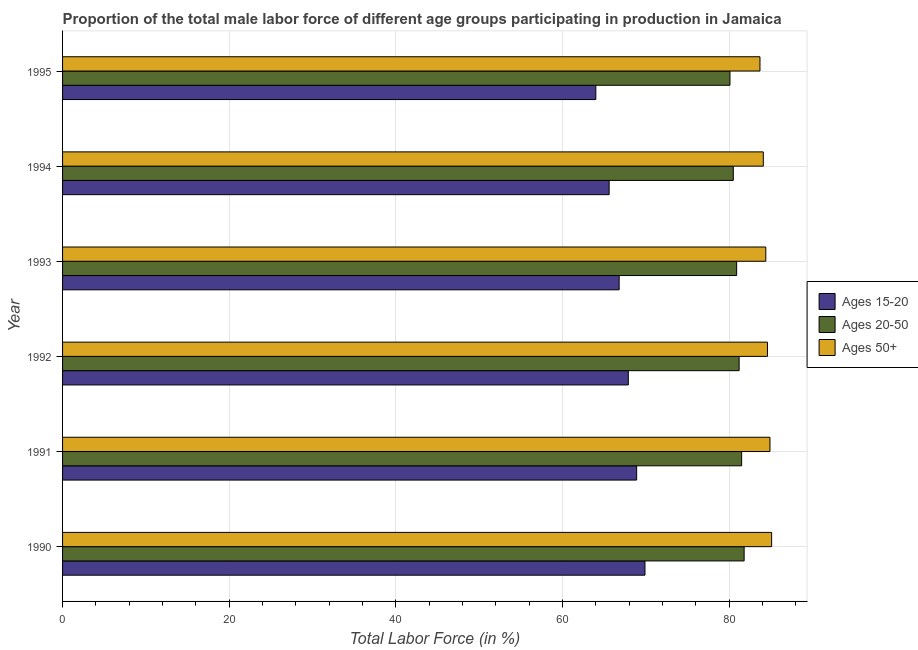How many bars are there on the 5th tick from the bottom?
Keep it short and to the point. 3. In how many cases, is the number of bars for a given year not equal to the number of legend labels?
Give a very brief answer. 0. What is the percentage of male labor force within the age group 20-50 in 1990?
Give a very brief answer. 81.8. Across all years, what is the maximum percentage of male labor force within the age group 15-20?
Provide a short and direct response. 69.9. Across all years, what is the minimum percentage of male labor force within the age group 20-50?
Provide a short and direct response. 80.1. What is the total percentage of male labor force within the age group 20-50 in the graph?
Ensure brevity in your answer.  486. What is the difference between the percentage of male labor force within the age group 15-20 in 1992 and that in 1994?
Your answer should be compact. 2.3. What is the difference between the percentage of male labor force within the age group 20-50 in 1995 and the percentage of male labor force within the age group 15-20 in 1990?
Give a very brief answer. 10.2. What is the average percentage of male labor force above age 50 per year?
Your answer should be compact. 84.47. In the year 1992, what is the difference between the percentage of male labor force within the age group 20-50 and percentage of male labor force above age 50?
Keep it short and to the point. -3.4. What is the ratio of the percentage of male labor force within the age group 15-20 in 1991 to that in 1995?
Give a very brief answer. 1.08. What is the difference between the highest and the second highest percentage of male labor force within the age group 15-20?
Offer a very short reply. 1. In how many years, is the percentage of male labor force within the age group 15-20 greater than the average percentage of male labor force within the age group 15-20 taken over all years?
Make the answer very short. 3. Is the sum of the percentage of male labor force within the age group 20-50 in 1992 and 1993 greater than the maximum percentage of male labor force above age 50 across all years?
Provide a short and direct response. Yes. What does the 3rd bar from the top in 1991 represents?
Keep it short and to the point. Ages 15-20. What does the 2nd bar from the bottom in 1995 represents?
Provide a short and direct response. Ages 20-50. Is it the case that in every year, the sum of the percentage of male labor force within the age group 15-20 and percentage of male labor force within the age group 20-50 is greater than the percentage of male labor force above age 50?
Your response must be concise. Yes. How many bars are there?
Provide a short and direct response. 18. Are all the bars in the graph horizontal?
Your answer should be compact. Yes. How many years are there in the graph?
Keep it short and to the point. 6. Does the graph contain any zero values?
Offer a terse response. No. Where does the legend appear in the graph?
Ensure brevity in your answer.  Center right. How many legend labels are there?
Keep it short and to the point. 3. What is the title of the graph?
Ensure brevity in your answer.  Proportion of the total male labor force of different age groups participating in production in Jamaica. Does "New Zealand" appear as one of the legend labels in the graph?
Make the answer very short. No. What is the label or title of the Y-axis?
Your response must be concise. Year. What is the Total Labor Force (in %) of Ages 15-20 in 1990?
Ensure brevity in your answer.  69.9. What is the Total Labor Force (in %) in Ages 20-50 in 1990?
Offer a very short reply. 81.8. What is the Total Labor Force (in %) in Ages 50+ in 1990?
Ensure brevity in your answer.  85.1. What is the Total Labor Force (in %) of Ages 15-20 in 1991?
Your response must be concise. 68.9. What is the Total Labor Force (in %) of Ages 20-50 in 1991?
Provide a short and direct response. 81.5. What is the Total Labor Force (in %) of Ages 50+ in 1991?
Your answer should be very brief. 84.9. What is the Total Labor Force (in %) in Ages 15-20 in 1992?
Keep it short and to the point. 67.9. What is the Total Labor Force (in %) of Ages 20-50 in 1992?
Your response must be concise. 81.2. What is the Total Labor Force (in %) in Ages 50+ in 1992?
Your answer should be compact. 84.6. What is the Total Labor Force (in %) in Ages 15-20 in 1993?
Make the answer very short. 66.8. What is the Total Labor Force (in %) of Ages 20-50 in 1993?
Your response must be concise. 80.9. What is the Total Labor Force (in %) in Ages 50+ in 1993?
Ensure brevity in your answer.  84.4. What is the Total Labor Force (in %) in Ages 15-20 in 1994?
Your response must be concise. 65.6. What is the Total Labor Force (in %) in Ages 20-50 in 1994?
Give a very brief answer. 80.5. What is the Total Labor Force (in %) in Ages 50+ in 1994?
Provide a short and direct response. 84.1. What is the Total Labor Force (in %) in Ages 15-20 in 1995?
Ensure brevity in your answer.  64. What is the Total Labor Force (in %) in Ages 20-50 in 1995?
Your answer should be compact. 80.1. What is the Total Labor Force (in %) of Ages 50+ in 1995?
Your answer should be compact. 83.7. Across all years, what is the maximum Total Labor Force (in %) in Ages 15-20?
Give a very brief answer. 69.9. Across all years, what is the maximum Total Labor Force (in %) in Ages 20-50?
Give a very brief answer. 81.8. Across all years, what is the maximum Total Labor Force (in %) in Ages 50+?
Keep it short and to the point. 85.1. Across all years, what is the minimum Total Labor Force (in %) of Ages 15-20?
Your response must be concise. 64. Across all years, what is the minimum Total Labor Force (in %) in Ages 20-50?
Ensure brevity in your answer.  80.1. Across all years, what is the minimum Total Labor Force (in %) in Ages 50+?
Make the answer very short. 83.7. What is the total Total Labor Force (in %) in Ages 15-20 in the graph?
Your answer should be very brief. 403.1. What is the total Total Labor Force (in %) in Ages 20-50 in the graph?
Keep it short and to the point. 486. What is the total Total Labor Force (in %) of Ages 50+ in the graph?
Provide a short and direct response. 506.8. What is the difference between the Total Labor Force (in %) in Ages 15-20 in 1990 and that in 1991?
Offer a terse response. 1. What is the difference between the Total Labor Force (in %) in Ages 50+ in 1990 and that in 1991?
Ensure brevity in your answer.  0.2. What is the difference between the Total Labor Force (in %) of Ages 15-20 in 1990 and that in 1992?
Provide a short and direct response. 2. What is the difference between the Total Labor Force (in %) of Ages 50+ in 1990 and that in 1993?
Provide a short and direct response. 0.7. What is the difference between the Total Labor Force (in %) of Ages 15-20 in 1990 and that in 1995?
Your answer should be compact. 5.9. What is the difference between the Total Labor Force (in %) in Ages 20-50 in 1990 and that in 1995?
Offer a very short reply. 1.7. What is the difference between the Total Labor Force (in %) in Ages 50+ in 1990 and that in 1995?
Offer a very short reply. 1.4. What is the difference between the Total Labor Force (in %) in Ages 20-50 in 1991 and that in 1992?
Provide a short and direct response. 0.3. What is the difference between the Total Labor Force (in %) of Ages 50+ in 1991 and that in 1992?
Make the answer very short. 0.3. What is the difference between the Total Labor Force (in %) of Ages 15-20 in 1991 and that in 1993?
Make the answer very short. 2.1. What is the difference between the Total Labor Force (in %) in Ages 15-20 in 1991 and that in 1994?
Provide a succinct answer. 3.3. What is the difference between the Total Labor Force (in %) in Ages 20-50 in 1991 and that in 1994?
Ensure brevity in your answer.  1. What is the difference between the Total Labor Force (in %) of Ages 50+ in 1991 and that in 1994?
Make the answer very short. 0.8. What is the difference between the Total Labor Force (in %) of Ages 15-20 in 1991 and that in 1995?
Offer a terse response. 4.9. What is the difference between the Total Labor Force (in %) of Ages 20-50 in 1991 and that in 1995?
Offer a very short reply. 1.4. What is the difference between the Total Labor Force (in %) of Ages 50+ in 1991 and that in 1995?
Provide a succinct answer. 1.2. What is the difference between the Total Labor Force (in %) of Ages 15-20 in 1992 and that in 1994?
Ensure brevity in your answer.  2.3. What is the difference between the Total Labor Force (in %) of Ages 50+ in 1992 and that in 1994?
Offer a terse response. 0.5. What is the difference between the Total Labor Force (in %) of Ages 15-20 in 1992 and that in 1995?
Keep it short and to the point. 3.9. What is the difference between the Total Labor Force (in %) in Ages 50+ in 1992 and that in 1995?
Offer a very short reply. 0.9. What is the difference between the Total Labor Force (in %) of Ages 50+ in 1993 and that in 1994?
Make the answer very short. 0.3. What is the difference between the Total Labor Force (in %) of Ages 20-50 in 1993 and that in 1995?
Offer a very short reply. 0.8. What is the difference between the Total Labor Force (in %) of Ages 50+ in 1993 and that in 1995?
Your answer should be very brief. 0.7. What is the difference between the Total Labor Force (in %) in Ages 20-50 in 1990 and the Total Labor Force (in %) in Ages 50+ in 1991?
Give a very brief answer. -3.1. What is the difference between the Total Labor Force (in %) in Ages 15-20 in 1990 and the Total Labor Force (in %) in Ages 50+ in 1992?
Provide a succinct answer. -14.7. What is the difference between the Total Labor Force (in %) in Ages 15-20 in 1990 and the Total Labor Force (in %) in Ages 50+ in 1993?
Offer a very short reply. -14.5. What is the difference between the Total Labor Force (in %) of Ages 20-50 in 1990 and the Total Labor Force (in %) of Ages 50+ in 1993?
Offer a terse response. -2.6. What is the difference between the Total Labor Force (in %) in Ages 15-20 in 1990 and the Total Labor Force (in %) in Ages 20-50 in 1995?
Offer a terse response. -10.2. What is the difference between the Total Labor Force (in %) of Ages 15-20 in 1991 and the Total Labor Force (in %) of Ages 50+ in 1992?
Your answer should be very brief. -15.7. What is the difference between the Total Labor Force (in %) of Ages 20-50 in 1991 and the Total Labor Force (in %) of Ages 50+ in 1992?
Make the answer very short. -3.1. What is the difference between the Total Labor Force (in %) in Ages 15-20 in 1991 and the Total Labor Force (in %) in Ages 50+ in 1993?
Ensure brevity in your answer.  -15.5. What is the difference between the Total Labor Force (in %) in Ages 15-20 in 1991 and the Total Labor Force (in %) in Ages 50+ in 1994?
Your response must be concise. -15.2. What is the difference between the Total Labor Force (in %) of Ages 20-50 in 1991 and the Total Labor Force (in %) of Ages 50+ in 1994?
Provide a succinct answer. -2.6. What is the difference between the Total Labor Force (in %) of Ages 15-20 in 1991 and the Total Labor Force (in %) of Ages 20-50 in 1995?
Make the answer very short. -11.2. What is the difference between the Total Labor Force (in %) in Ages 15-20 in 1991 and the Total Labor Force (in %) in Ages 50+ in 1995?
Give a very brief answer. -14.8. What is the difference between the Total Labor Force (in %) of Ages 20-50 in 1991 and the Total Labor Force (in %) of Ages 50+ in 1995?
Keep it short and to the point. -2.2. What is the difference between the Total Labor Force (in %) in Ages 15-20 in 1992 and the Total Labor Force (in %) in Ages 20-50 in 1993?
Make the answer very short. -13. What is the difference between the Total Labor Force (in %) in Ages 15-20 in 1992 and the Total Labor Force (in %) in Ages 50+ in 1993?
Your answer should be very brief. -16.5. What is the difference between the Total Labor Force (in %) in Ages 15-20 in 1992 and the Total Labor Force (in %) in Ages 50+ in 1994?
Provide a short and direct response. -16.2. What is the difference between the Total Labor Force (in %) in Ages 15-20 in 1992 and the Total Labor Force (in %) in Ages 20-50 in 1995?
Make the answer very short. -12.2. What is the difference between the Total Labor Force (in %) in Ages 15-20 in 1992 and the Total Labor Force (in %) in Ages 50+ in 1995?
Give a very brief answer. -15.8. What is the difference between the Total Labor Force (in %) in Ages 20-50 in 1992 and the Total Labor Force (in %) in Ages 50+ in 1995?
Provide a short and direct response. -2.5. What is the difference between the Total Labor Force (in %) in Ages 15-20 in 1993 and the Total Labor Force (in %) in Ages 20-50 in 1994?
Your answer should be compact. -13.7. What is the difference between the Total Labor Force (in %) in Ages 15-20 in 1993 and the Total Labor Force (in %) in Ages 50+ in 1994?
Provide a succinct answer. -17.3. What is the difference between the Total Labor Force (in %) of Ages 20-50 in 1993 and the Total Labor Force (in %) of Ages 50+ in 1994?
Keep it short and to the point. -3.2. What is the difference between the Total Labor Force (in %) of Ages 15-20 in 1993 and the Total Labor Force (in %) of Ages 50+ in 1995?
Offer a terse response. -16.9. What is the difference between the Total Labor Force (in %) in Ages 20-50 in 1993 and the Total Labor Force (in %) in Ages 50+ in 1995?
Your response must be concise. -2.8. What is the difference between the Total Labor Force (in %) of Ages 15-20 in 1994 and the Total Labor Force (in %) of Ages 50+ in 1995?
Ensure brevity in your answer.  -18.1. What is the average Total Labor Force (in %) in Ages 15-20 per year?
Provide a short and direct response. 67.18. What is the average Total Labor Force (in %) of Ages 50+ per year?
Make the answer very short. 84.47. In the year 1990, what is the difference between the Total Labor Force (in %) of Ages 15-20 and Total Labor Force (in %) of Ages 20-50?
Offer a terse response. -11.9. In the year 1990, what is the difference between the Total Labor Force (in %) in Ages 15-20 and Total Labor Force (in %) in Ages 50+?
Give a very brief answer. -15.2. In the year 1990, what is the difference between the Total Labor Force (in %) in Ages 20-50 and Total Labor Force (in %) in Ages 50+?
Give a very brief answer. -3.3. In the year 1991, what is the difference between the Total Labor Force (in %) of Ages 15-20 and Total Labor Force (in %) of Ages 20-50?
Your response must be concise. -12.6. In the year 1991, what is the difference between the Total Labor Force (in %) in Ages 15-20 and Total Labor Force (in %) in Ages 50+?
Your answer should be compact. -16. In the year 1991, what is the difference between the Total Labor Force (in %) in Ages 20-50 and Total Labor Force (in %) in Ages 50+?
Offer a very short reply. -3.4. In the year 1992, what is the difference between the Total Labor Force (in %) in Ages 15-20 and Total Labor Force (in %) in Ages 50+?
Your answer should be very brief. -16.7. In the year 1992, what is the difference between the Total Labor Force (in %) of Ages 20-50 and Total Labor Force (in %) of Ages 50+?
Your response must be concise. -3.4. In the year 1993, what is the difference between the Total Labor Force (in %) of Ages 15-20 and Total Labor Force (in %) of Ages 20-50?
Your answer should be compact. -14.1. In the year 1993, what is the difference between the Total Labor Force (in %) in Ages 15-20 and Total Labor Force (in %) in Ages 50+?
Make the answer very short. -17.6. In the year 1993, what is the difference between the Total Labor Force (in %) in Ages 20-50 and Total Labor Force (in %) in Ages 50+?
Your answer should be very brief. -3.5. In the year 1994, what is the difference between the Total Labor Force (in %) in Ages 15-20 and Total Labor Force (in %) in Ages 20-50?
Give a very brief answer. -14.9. In the year 1994, what is the difference between the Total Labor Force (in %) of Ages 15-20 and Total Labor Force (in %) of Ages 50+?
Give a very brief answer. -18.5. In the year 1994, what is the difference between the Total Labor Force (in %) of Ages 20-50 and Total Labor Force (in %) of Ages 50+?
Make the answer very short. -3.6. In the year 1995, what is the difference between the Total Labor Force (in %) of Ages 15-20 and Total Labor Force (in %) of Ages 20-50?
Keep it short and to the point. -16.1. In the year 1995, what is the difference between the Total Labor Force (in %) in Ages 15-20 and Total Labor Force (in %) in Ages 50+?
Make the answer very short. -19.7. In the year 1995, what is the difference between the Total Labor Force (in %) of Ages 20-50 and Total Labor Force (in %) of Ages 50+?
Keep it short and to the point. -3.6. What is the ratio of the Total Labor Force (in %) in Ages 15-20 in 1990 to that in 1991?
Your answer should be very brief. 1.01. What is the ratio of the Total Labor Force (in %) in Ages 20-50 in 1990 to that in 1991?
Your answer should be very brief. 1. What is the ratio of the Total Labor Force (in %) of Ages 15-20 in 1990 to that in 1992?
Your answer should be very brief. 1.03. What is the ratio of the Total Labor Force (in %) of Ages 20-50 in 1990 to that in 1992?
Your answer should be very brief. 1.01. What is the ratio of the Total Labor Force (in %) of Ages 50+ in 1990 to that in 1992?
Provide a short and direct response. 1.01. What is the ratio of the Total Labor Force (in %) in Ages 15-20 in 1990 to that in 1993?
Your answer should be compact. 1.05. What is the ratio of the Total Labor Force (in %) in Ages 20-50 in 1990 to that in 1993?
Keep it short and to the point. 1.01. What is the ratio of the Total Labor Force (in %) in Ages 50+ in 1990 to that in 1993?
Offer a very short reply. 1.01. What is the ratio of the Total Labor Force (in %) of Ages 15-20 in 1990 to that in 1994?
Ensure brevity in your answer.  1.07. What is the ratio of the Total Labor Force (in %) of Ages 20-50 in 1990 to that in 1994?
Ensure brevity in your answer.  1.02. What is the ratio of the Total Labor Force (in %) of Ages 50+ in 1990 to that in 1994?
Offer a very short reply. 1.01. What is the ratio of the Total Labor Force (in %) in Ages 15-20 in 1990 to that in 1995?
Provide a short and direct response. 1.09. What is the ratio of the Total Labor Force (in %) of Ages 20-50 in 1990 to that in 1995?
Ensure brevity in your answer.  1.02. What is the ratio of the Total Labor Force (in %) in Ages 50+ in 1990 to that in 1995?
Make the answer very short. 1.02. What is the ratio of the Total Labor Force (in %) of Ages 15-20 in 1991 to that in 1992?
Make the answer very short. 1.01. What is the ratio of the Total Labor Force (in %) in Ages 20-50 in 1991 to that in 1992?
Keep it short and to the point. 1. What is the ratio of the Total Labor Force (in %) of Ages 50+ in 1991 to that in 1992?
Your answer should be very brief. 1. What is the ratio of the Total Labor Force (in %) of Ages 15-20 in 1991 to that in 1993?
Keep it short and to the point. 1.03. What is the ratio of the Total Labor Force (in %) of Ages 20-50 in 1991 to that in 1993?
Give a very brief answer. 1.01. What is the ratio of the Total Labor Force (in %) in Ages 50+ in 1991 to that in 1993?
Make the answer very short. 1.01. What is the ratio of the Total Labor Force (in %) in Ages 15-20 in 1991 to that in 1994?
Your response must be concise. 1.05. What is the ratio of the Total Labor Force (in %) in Ages 20-50 in 1991 to that in 1994?
Offer a very short reply. 1.01. What is the ratio of the Total Labor Force (in %) of Ages 50+ in 1991 to that in 1994?
Give a very brief answer. 1.01. What is the ratio of the Total Labor Force (in %) in Ages 15-20 in 1991 to that in 1995?
Make the answer very short. 1.08. What is the ratio of the Total Labor Force (in %) of Ages 20-50 in 1991 to that in 1995?
Offer a very short reply. 1.02. What is the ratio of the Total Labor Force (in %) of Ages 50+ in 1991 to that in 1995?
Your answer should be compact. 1.01. What is the ratio of the Total Labor Force (in %) in Ages 15-20 in 1992 to that in 1993?
Offer a terse response. 1.02. What is the ratio of the Total Labor Force (in %) in Ages 20-50 in 1992 to that in 1993?
Provide a succinct answer. 1. What is the ratio of the Total Labor Force (in %) of Ages 15-20 in 1992 to that in 1994?
Offer a very short reply. 1.04. What is the ratio of the Total Labor Force (in %) of Ages 20-50 in 1992 to that in 1994?
Offer a terse response. 1.01. What is the ratio of the Total Labor Force (in %) in Ages 50+ in 1992 to that in 1994?
Ensure brevity in your answer.  1.01. What is the ratio of the Total Labor Force (in %) in Ages 15-20 in 1992 to that in 1995?
Your answer should be compact. 1.06. What is the ratio of the Total Labor Force (in %) of Ages 20-50 in 1992 to that in 1995?
Ensure brevity in your answer.  1.01. What is the ratio of the Total Labor Force (in %) in Ages 50+ in 1992 to that in 1995?
Keep it short and to the point. 1.01. What is the ratio of the Total Labor Force (in %) in Ages 15-20 in 1993 to that in 1994?
Your answer should be very brief. 1.02. What is the ratio of the Total Labor Force (in %) in Ages 15-20 in 1993 to that in 1995?
Provide a short and direct response. 1.04. What is the ratio of the Total Labor Force (in %) in Ages 20-50 in 1993 to that in 1995?
Your answer should be compact. 1.01. What is the ratio of the Total Labor Force (in %) of Ages 50+ in 1993 to that in 1995?
Make the answer very short. 1.01. What is the ratio of the Total Labor Force (in %) in Ages 20-50 in 1994 to that in 1995?
Your response must be concise. 1. What is the difference between the highest and the second highest Total Labor Force (in %) of Ages 20-50?
Your response must be concise. 0.3. What is the difference between the highest and the lowest Total Labor Force (in %) of Ages 15-20?
Offer a very short reply. 5.9. What is the difference between the highest and the lowest Total Labor Force (in %) in Ages 20-50?
Your response must be concise. 1.7. 